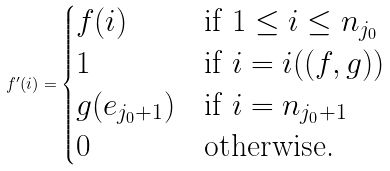<formula> <loc_0><loc_0><loc_500><loc_500>f ^ { \prime } ( i ) = \begin{cases} f ( i ) & \text {if $1 \leq i \leq n_{j_{0}}$} \\ 1 & \text {if $i= i((f,g))$} \\ g ( e _ { j _ { 0 } + 1 } ) & \text {if $i = n_{j_{0}+1}$} \\ 0 & \text {otherwise.} \end{cases}</formula> 